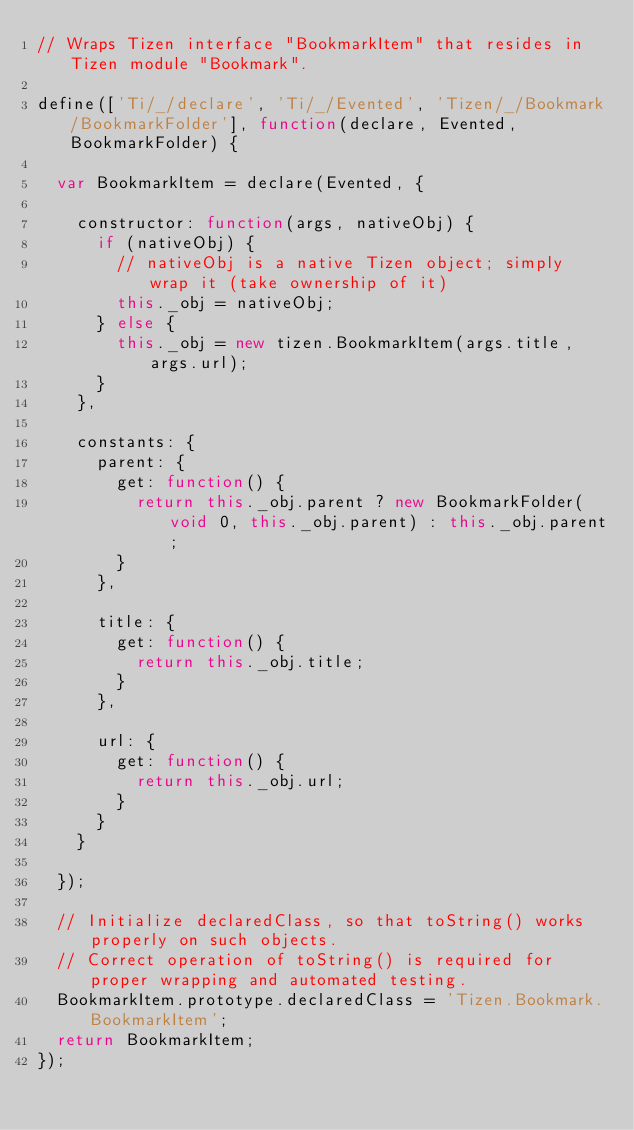<code> <loc_0><loc_0><loc_500><loc_500><_JavaScript_>// Wraps Tizen interface "BookmarkItem" that resides in Tizen module "Bookmark".

define(['Ti/_/declare', 'Ti/_/Evented', 'Tizen/_/Bookmark/BookmarkFolder'], function(declare, Evented, BookmarkFolder) {

	var BookmarkItem = declare(Evented, {

		constructor: function(args, nativeObj) {
			if (nativeObj) {
				// nativeObj is a native Tizen object; simply wrap it (take ownership of it)
				this._obj = nativeObj;
			} else {
				this._obj = new tizen.BookmarkItem(args.title, args.url);
			}
		},

		constants: {
			parent: {
				get: function() {
					return this._obj.parent ? new BookmarkFolder(void 0, this._obj.parent) : this._obj.parent;
				}
			},

			title: {
				get: function() {
					return this._obj.title;
				}
			},

			url: {
				get: function() {
					return this._obj.url;
				}
			}
		}

	});

	// Initialize declaredClass, so that toString() works properly on such objects.
	// Correct operation of toString() is required for proper wrapping and automated testing.
	BookmarkItem.prototype.declaredClass = 'Tizen.Bookmark.BookmarkItem';
	return BookmarkItem;
});</code> 